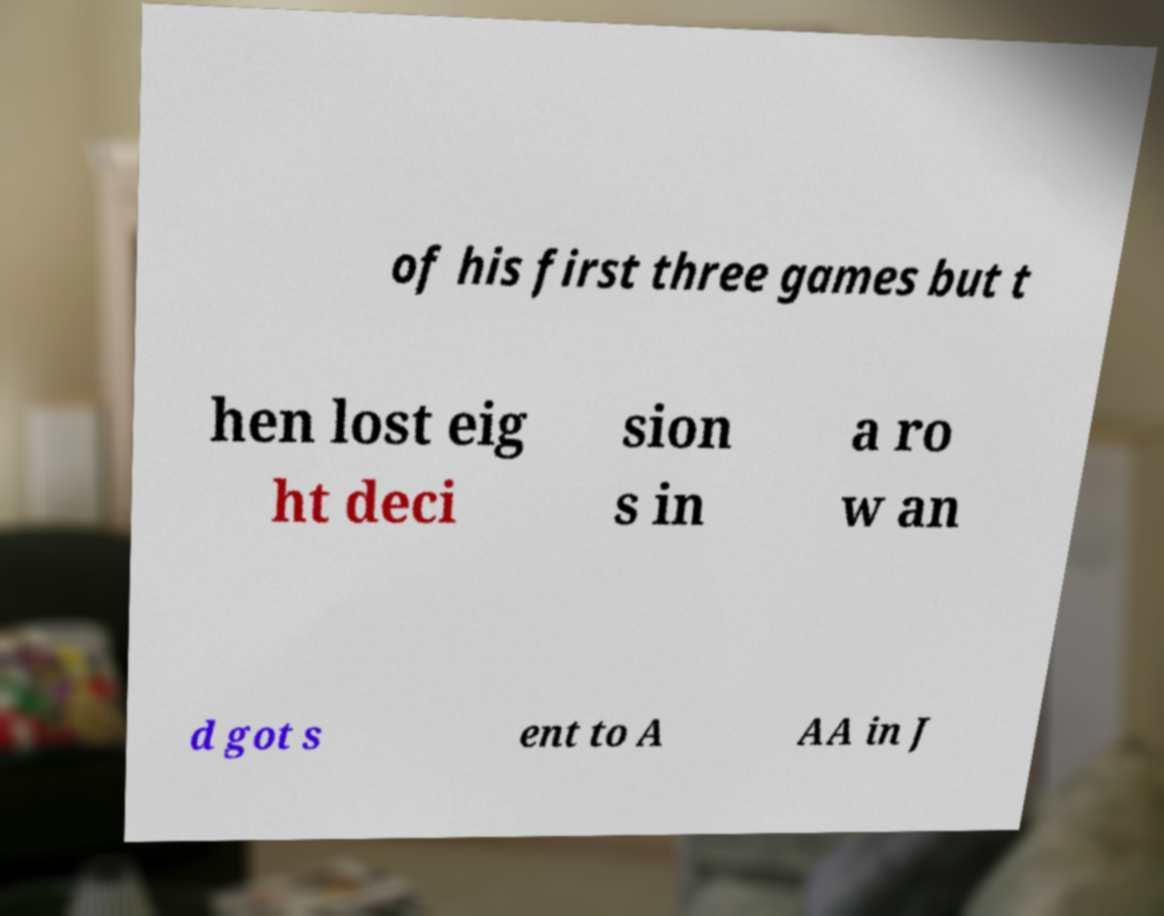There's text embedded in this image that I need extracted. Can you transcribe it verbatim? of his first three games but t hen lost eig ht deci sion s in a ro w an d got s ent to A AA in J 